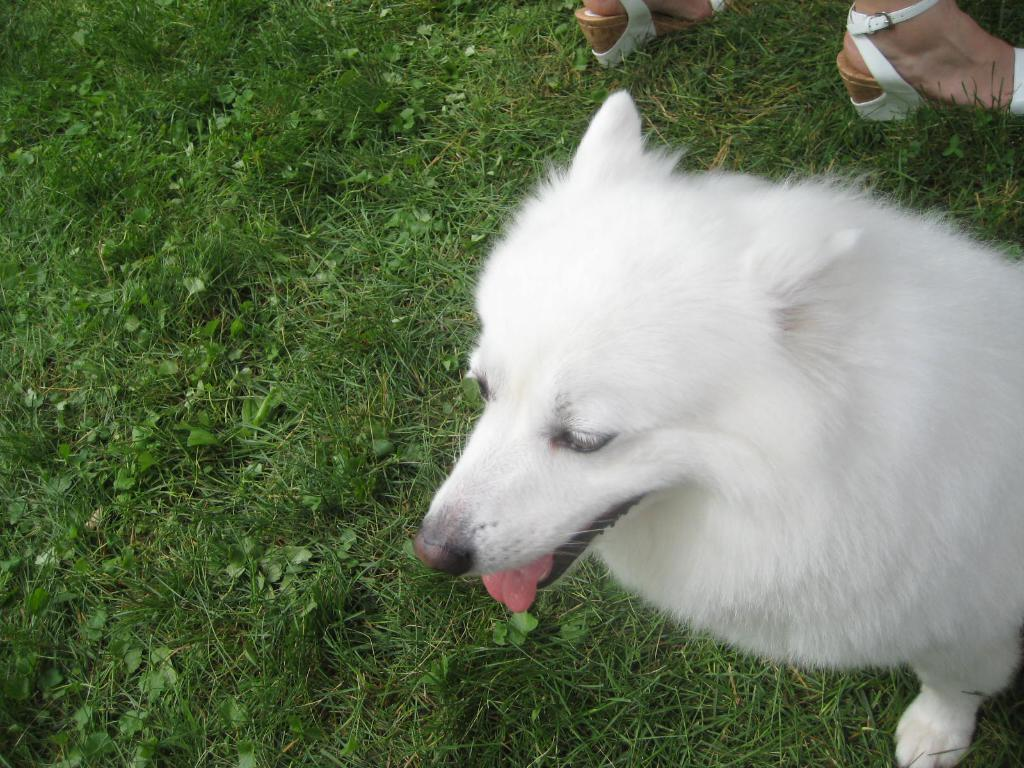What type of animal is in the image? There is a white color dog in the image. Where is the dog located? The dog is sitting on the grass. What is the grass situated on? The grass is on the ground. Is there a person in the image? Yes, there is a person standing on the ground. How close is the dog to the person? The dog is near the person. What type of business is the dog involved in within the image? There is no indication of a business in the image; it features a dog sitting on the grass near a person. 